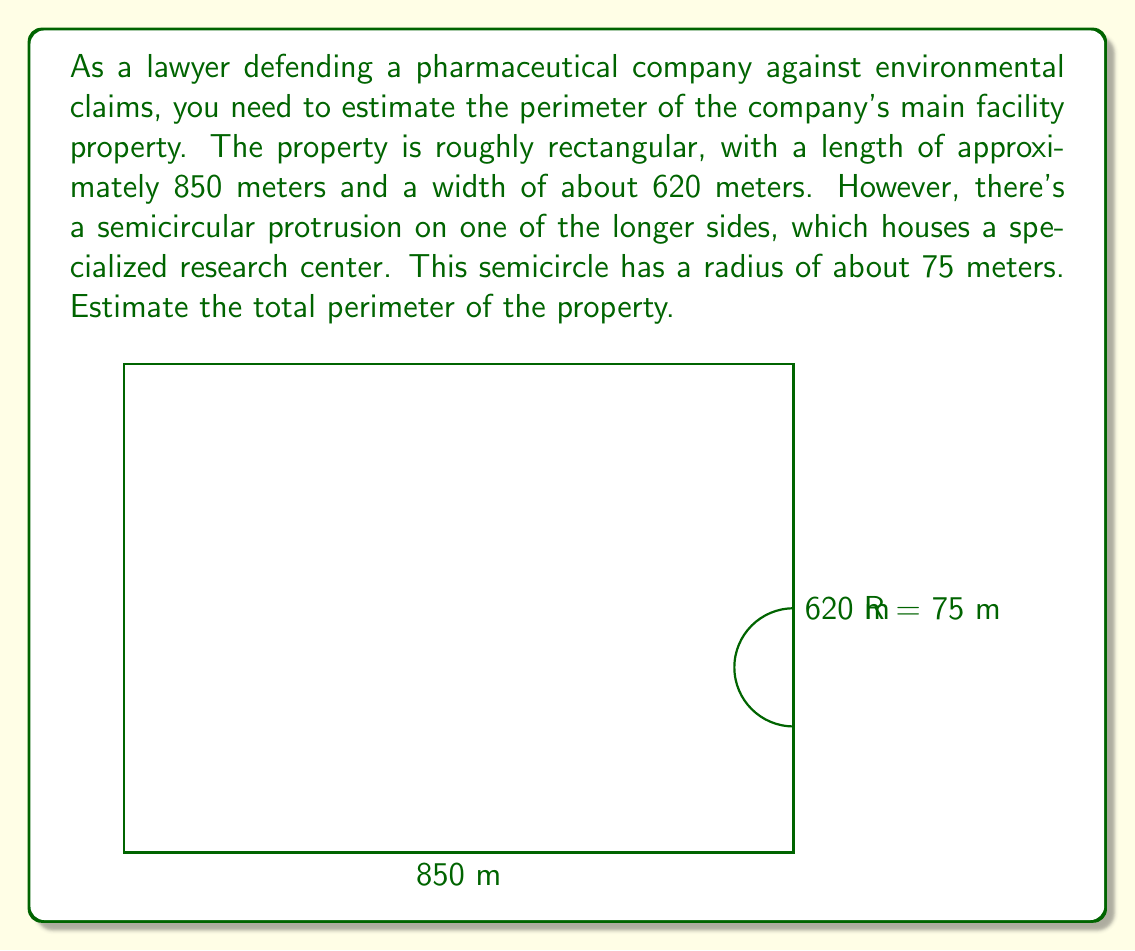Can you solve this math problem? To estimate the perimeter of the property, we need to:

1. Calculate the perimeter of the rectangle:
   $$P_{rectangle} = 2(l + w) = 2(850 + 620) = 2(1470) = 2940\text{ meters}$$

2. Calculate the length of the straight side replaced by the semicircle:
   $$\text{Replaced length} = 2r = 2(75) = 150\text{ meters}$$

3. Calculate the length of the semicircular arc:
   $$\text{Arc length} = \pi r = \pi(75) \approx 235.62\text{ meters}$$

4. Adjust the perimeter by subtracting the replaced length and adding the arc length:
   $$\begin{align}
   P_{total} &= P_{rectangle} - \text{Replaced length} + \text{Arc length} \\
   &= 2940 - 150 + 235.62 \\
   &\approx 3025.62\text{ meters}
   \end{align}$$

Rounding to the nearest meter for a reasonable estimate:
$$P_{total} \approx 3026\text{ meters}$$
Answer: The estimated perimeter of the pharmaceutical facility's property is approximately 3026 meters. 